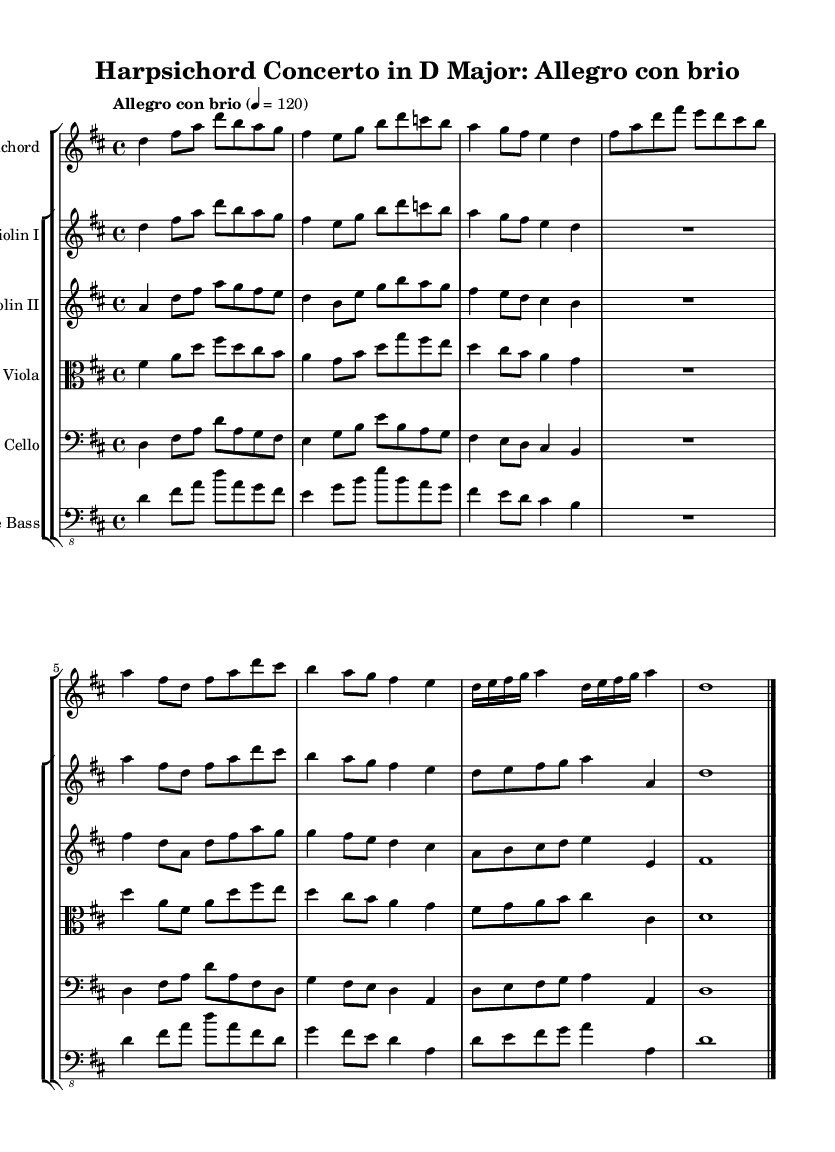What is the key signature of this music? The key signature is D major, which has two sharps (F# and C#).
Answer: D major What is the time signature of this music? The time signature is 4/4, indicating four beats per measure.
Answer: 4/4 What is the tempo marking for this piece? The tempo marking indicates "Allegro con brio," which suggests a lively and vigorous pace.
Answer: Allegro con brio How many measures are in the harpsichord part? By counting the measures in the harpsichord line, there are eight measures.
Answer: Eight What instruments are included in this concerto? The concerto includes harpsichord, two violins, viola, cello, and double bass.
Answer: Harpsichord, two violins, viola, cello, double bass What is the main theme's initial note in the harpsichord part? The initial note of the harpsichord part is D, which serves as the starting point of the main theme.
Answer: D What distinguishes the concertos of the Baroque period from later styles? Baroque concertos often feature contrast between solo instruments and orchestral accompaniment, as well as intricate counterpoint.
Answer: Contrast and counterpoint 